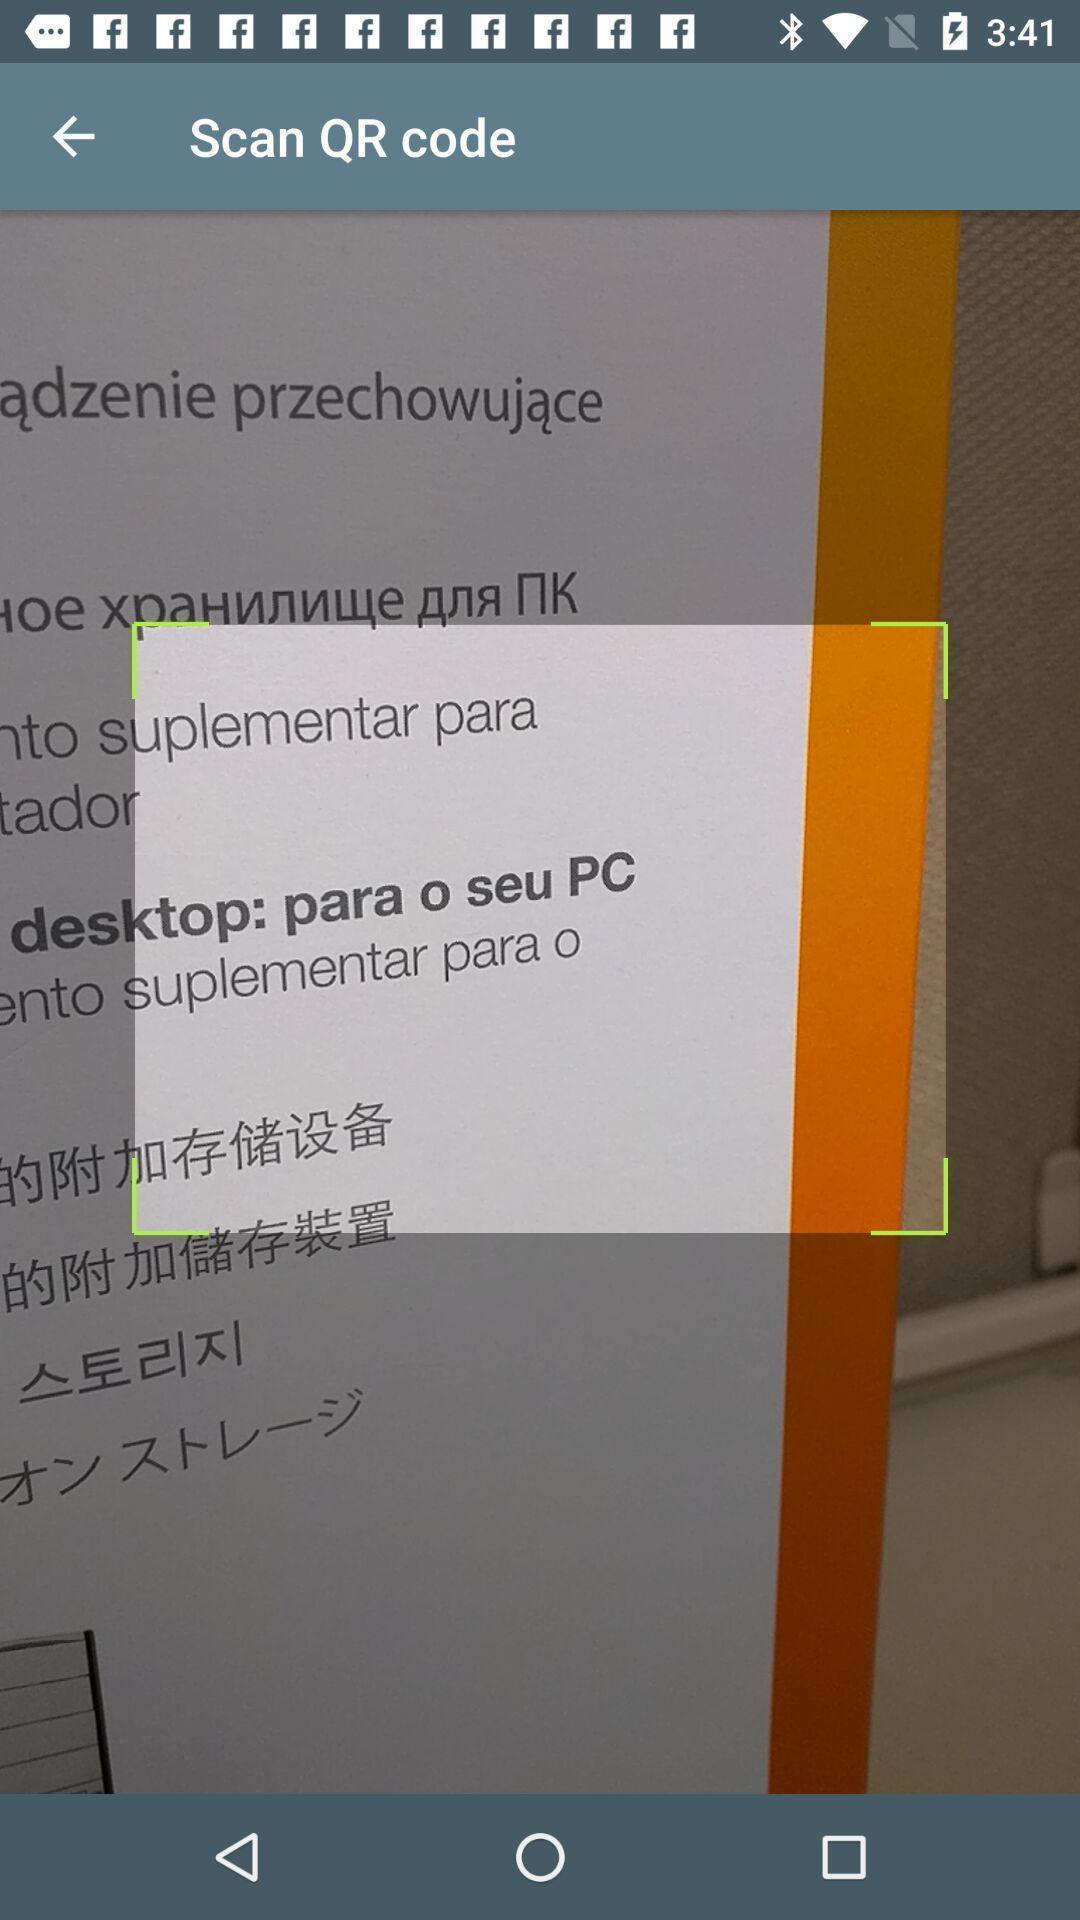What can you discern from this picture? Screen shows scanning an image. 